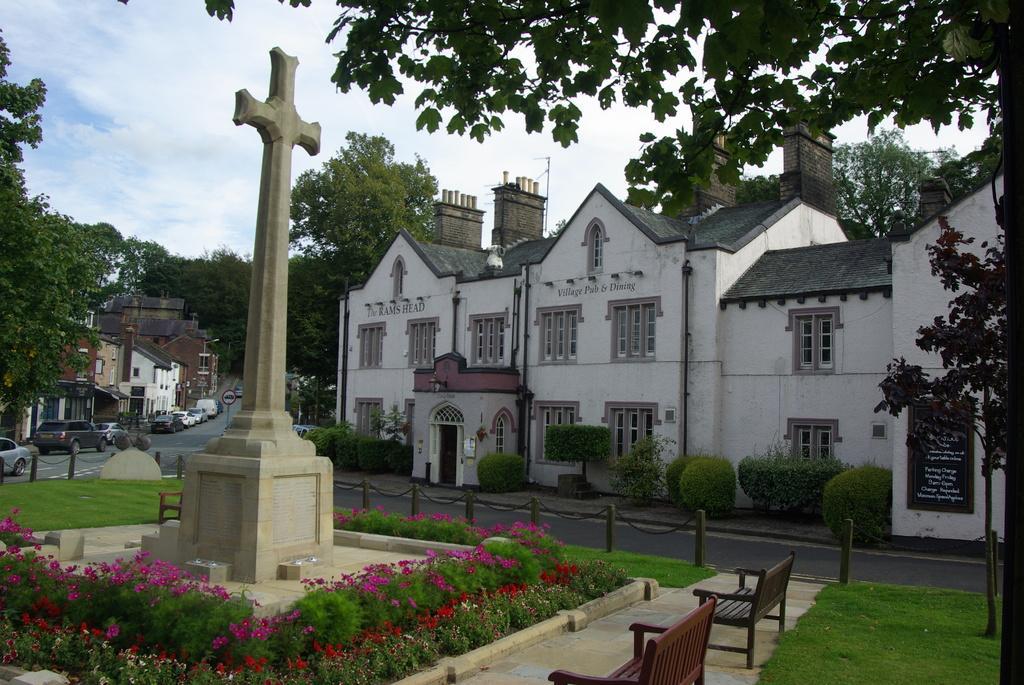In one or two sentences, can you explain what this image depicts? In this picture I can see buildings and few cars parked and I can see trees and a cross and I can see few plants with flowers and I can see couple of benches and a blue cloudy sky. 